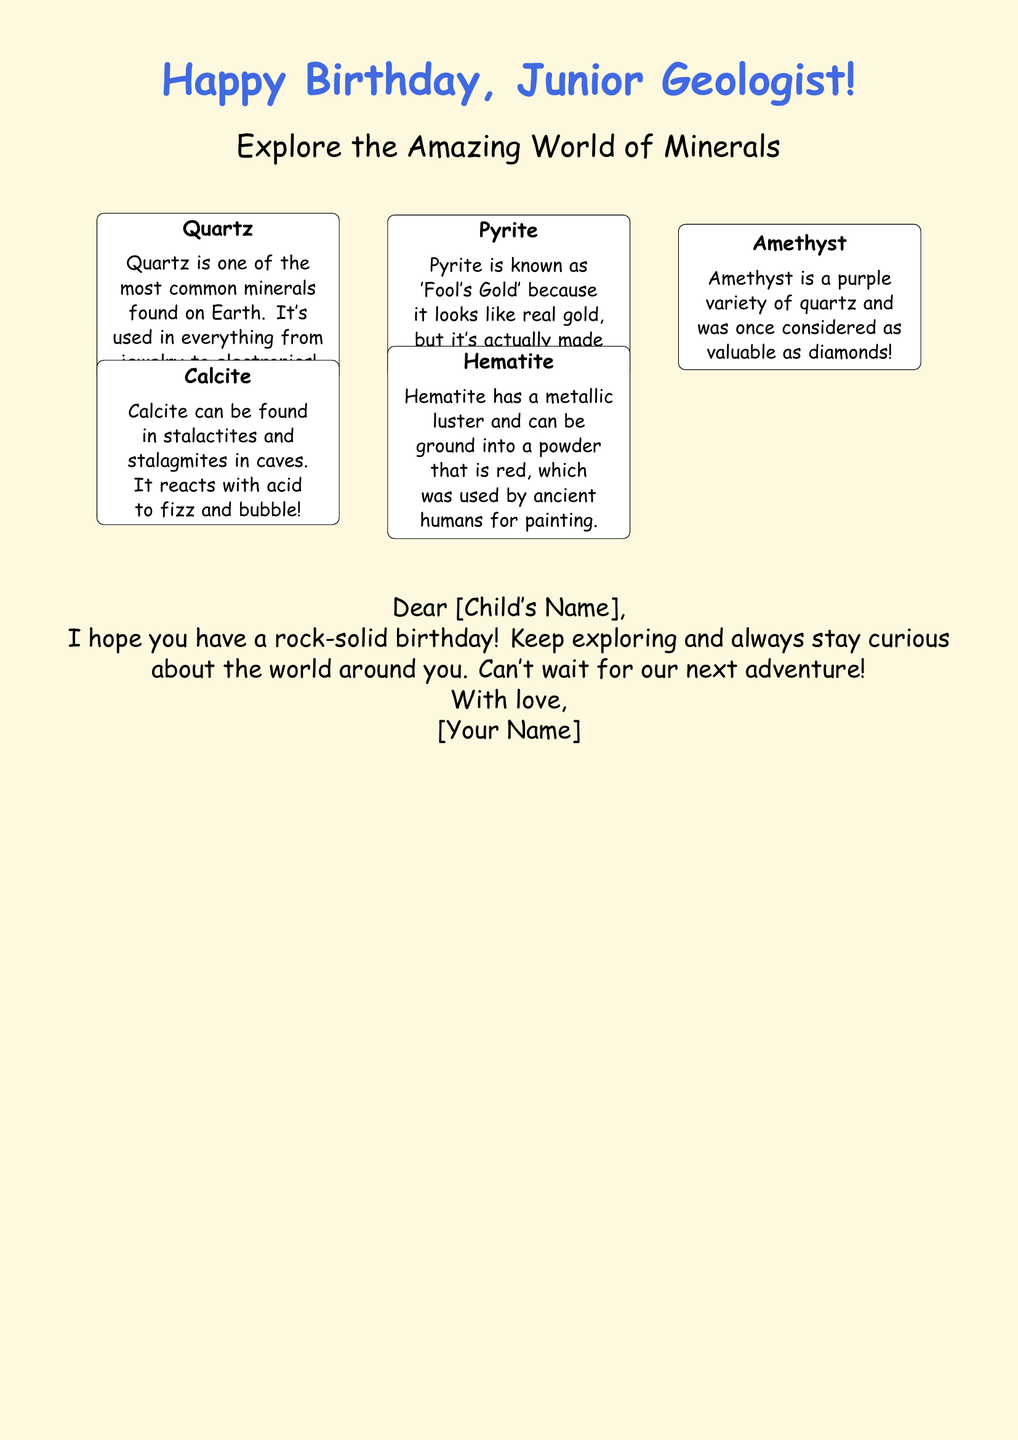What is the title of the card? The title of the card is prominently displayed at the top in a large font.
Answer: Happy Birthday, Junior Geologist! How many minerals are illustrated on the card? The card includes illustrations and facts about five different minerals.
Answer: 5 Which mineral is known as 'Fool's Gold'? This term is specified in the description of the mineral that resembles real gold but is not.
Answer: Pyrite What color variety is Amethyst? The card explicitly describes the unique color associated with Amethyst.
Answer: Purple What reaction does Calcite have with acid? The card provides a specific description of Calcite's reaction to a certain substance.
Answer: Fizz and bubble What wish is made for the child in the card? The closing message expresses a specific sentiment related to the child’s special day.
Answer: Rock-solid birthday Who is the card from? The card includes a personalized section indicating who the message is from.
Answer: [Your Name] 